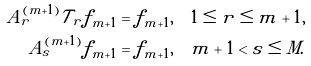Convert formula to latex. <formula><loc_0><loc_0><loc_500><loc_500>A _ { r } ^ { ( m + 1 ) } \mathcal { T } _ { r } f _ { m + 1 } & = f _ { m + 1 } , \quad 1 \leq r \leq m + 1 , \\ A _ { s } ^ { ( m + 1 ) } f _ { m + 1 } & = f _ { m + 1 } , \quad m + 1 < s \leq M .</formula> 